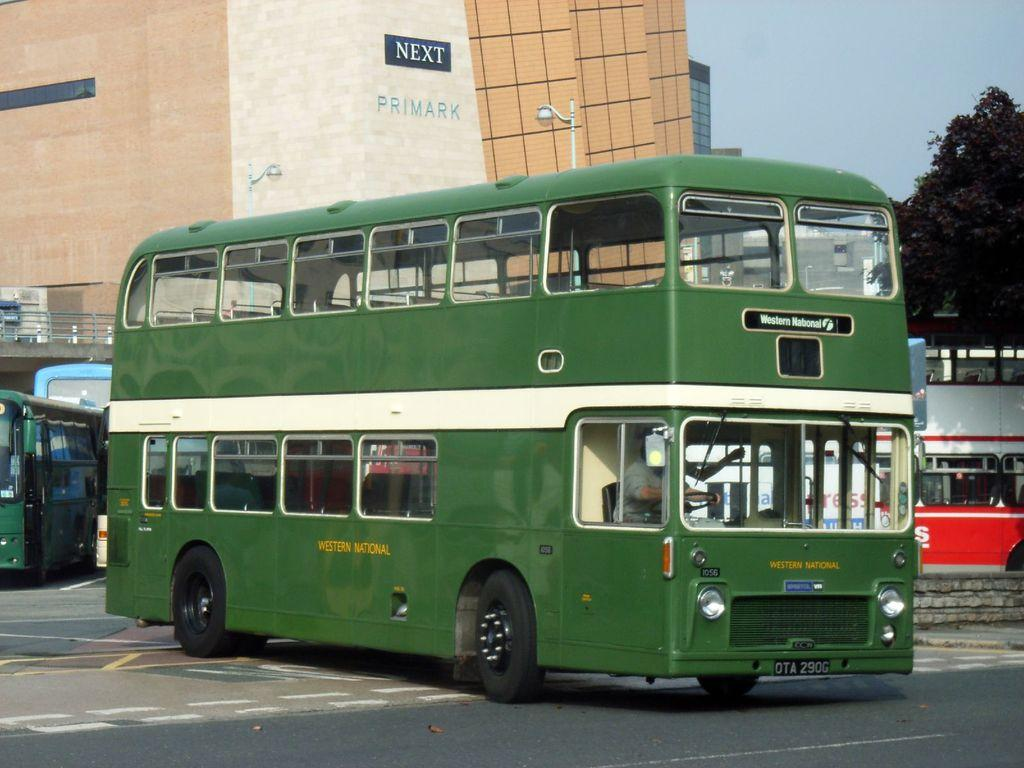What type of vehicle is in the image? There is a green color bus in the image. What is the bus doing in the image? The bus is moving on the road. What can be seen behind the bus in the image? There is a building behind the bus. What type of vegetation is on the right side of the image? There are trees on the right side of the image. Can you see any curtains hanging in the windows of the bus in the image? There is no information about curtains in the image, as it only shows a green color bus moving on the road. 